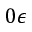Convert formula to latex. <formula><loc_0><loc_0><loc_500><loc_500>0 \epsilon</formula> 